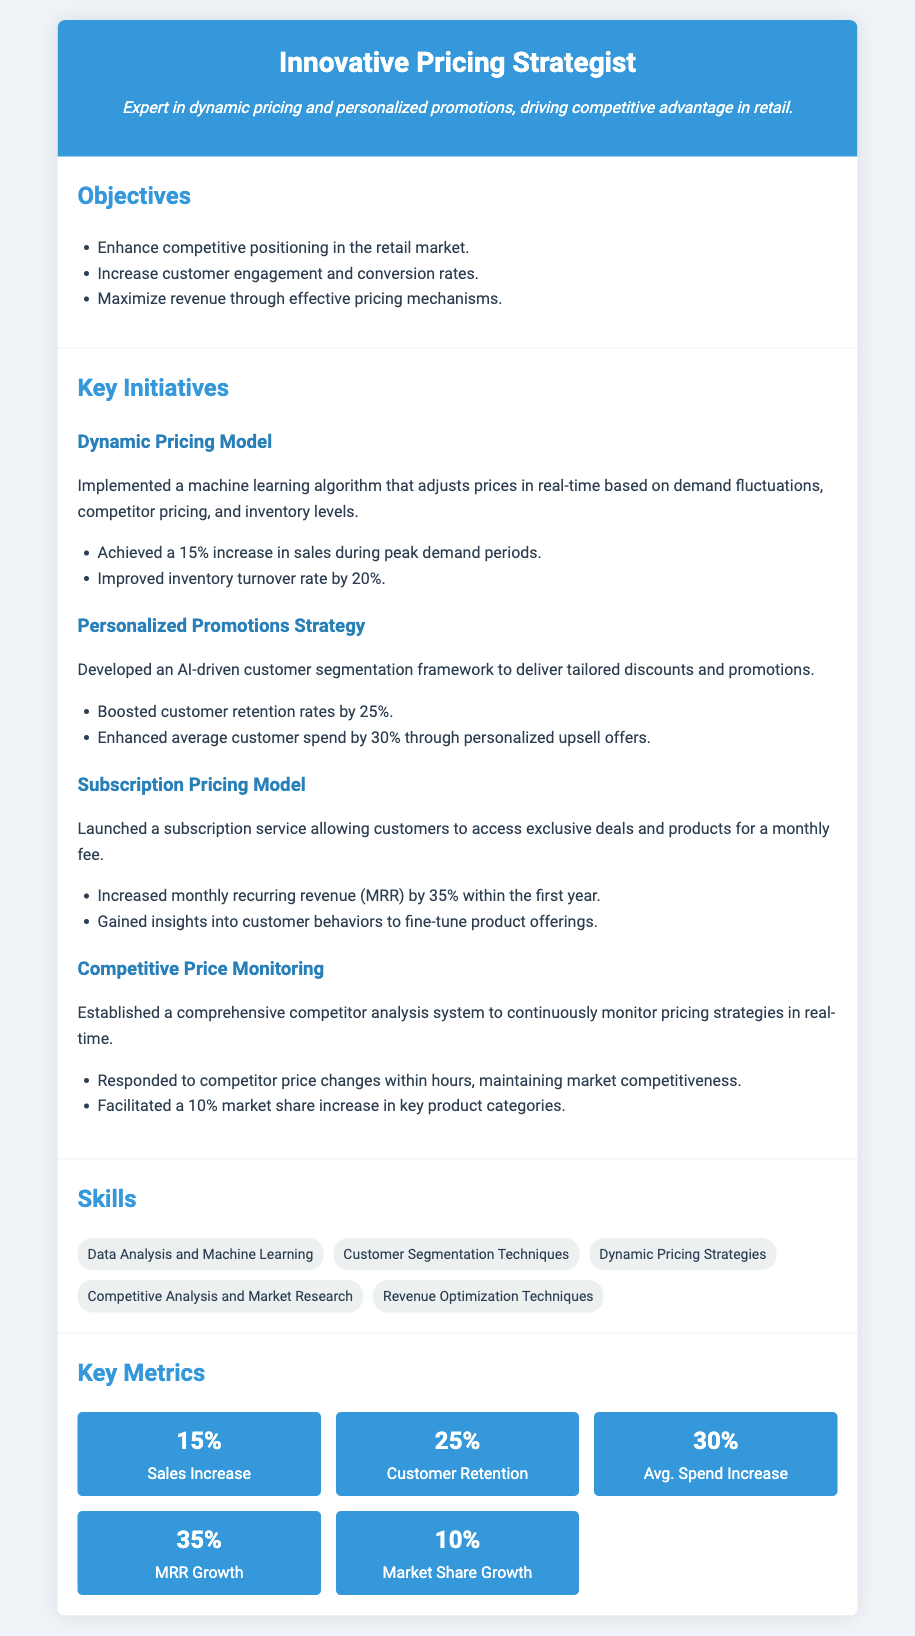what is the main objective of the pricing strategy? The main objective is to enhance competitive positioning in the retail market.
Answer: enhance competitive positioning how much did sales increase during peak demand periods? The document states that sales increased by 15% during peak demand periods.
Answer: 15% what was the percentage increase in customer retention rates? According to the document, customer retention rates increased by 25%.
Answer: 25% what key initiative involved machine learning algorithms? The key initiative that involved machine learning algorithms is the Dynamic Pricing Model.
Answer: Dynamic Pricing Model what was the growth in monthly recurring revenue within the first year of the subscription service? The growth in monthly recurring revenue was 35% within the first year.
Answer: 35% how did the competitive price monitoring initiative impact market share? The initiative facilitated a 10% market share increase in key product categories.
Answer: 10% which skill focuses on analyzing customer behavior? The skill that focuses on analyzing customer behavior is Customer Segmentation Techniques.
Answer: Customer Segmentation Techniques what was the average customer spend increase achieved through personalized upsell offers? The average customer spend increased by 30% through personalized upsell offers.
Answer: 30% 